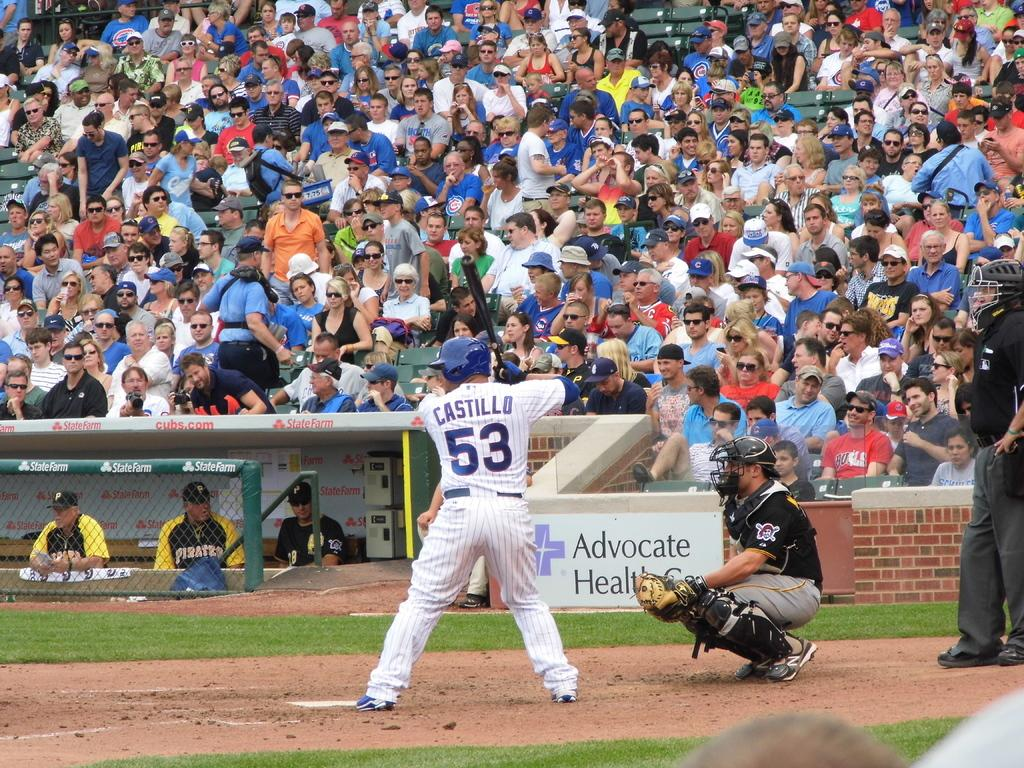<image>
Render a clear and concise summary of the photo. the batter is wearing a number 53 jersey 